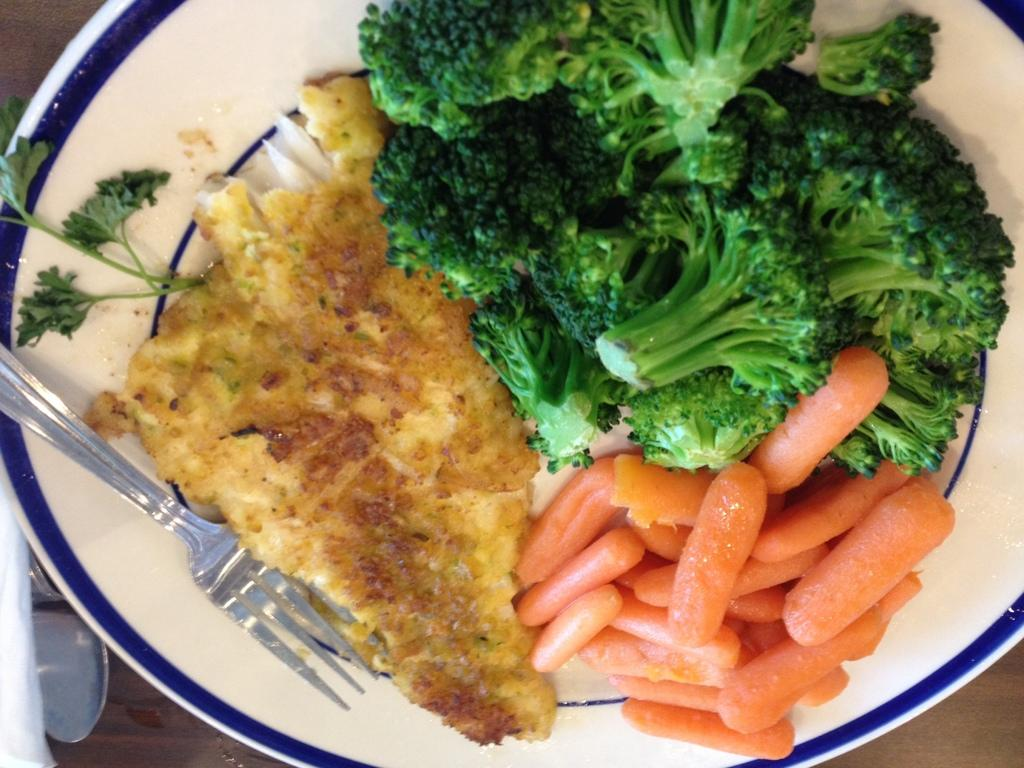What is located in the center of the image? There is a table in the center of the image. What utensils can be seen on the table? There is a spoon and a fork on the table. What is placed on the table for serving food? There is a plate on the table. What is on the plate? There is a food item on the plate. What type of cork can be seen in the image? There is no cork present in the image. What order are the utensils arranged in the image? The arrangement of utensils cannot be determined from the image alone, as it only shows a spoon and a fork on the table. 